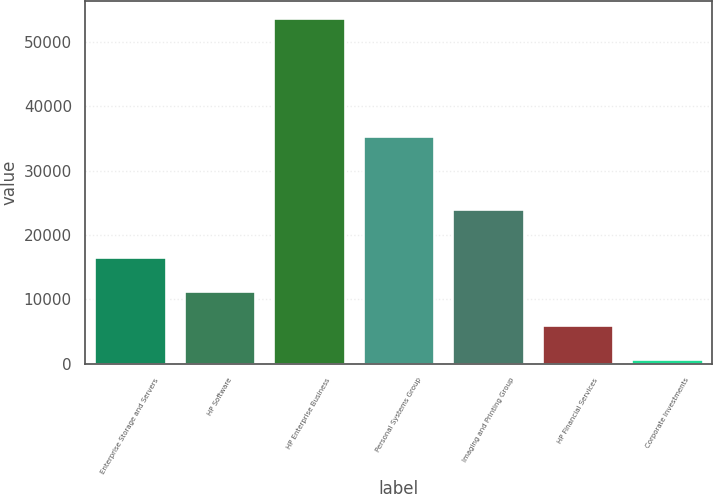Convert chart. <chart><loc_0><loc_0><loc_500><loc_500><bar_chart><fcel>Enterprise Storage and Servers<fcel>HP Software<fcel>HP Enterprise Business<fcel>Personal Systems Group<fcel>Imaging and Printing Group<fcel>HP Financial Services<fcel>Corporate Investments<nl><fcel>16624.8<fcel>11339.2<fcel>53624<fcel>35305<fcel>24011<fcel>6053.6<fcel>768<nl></chart> 